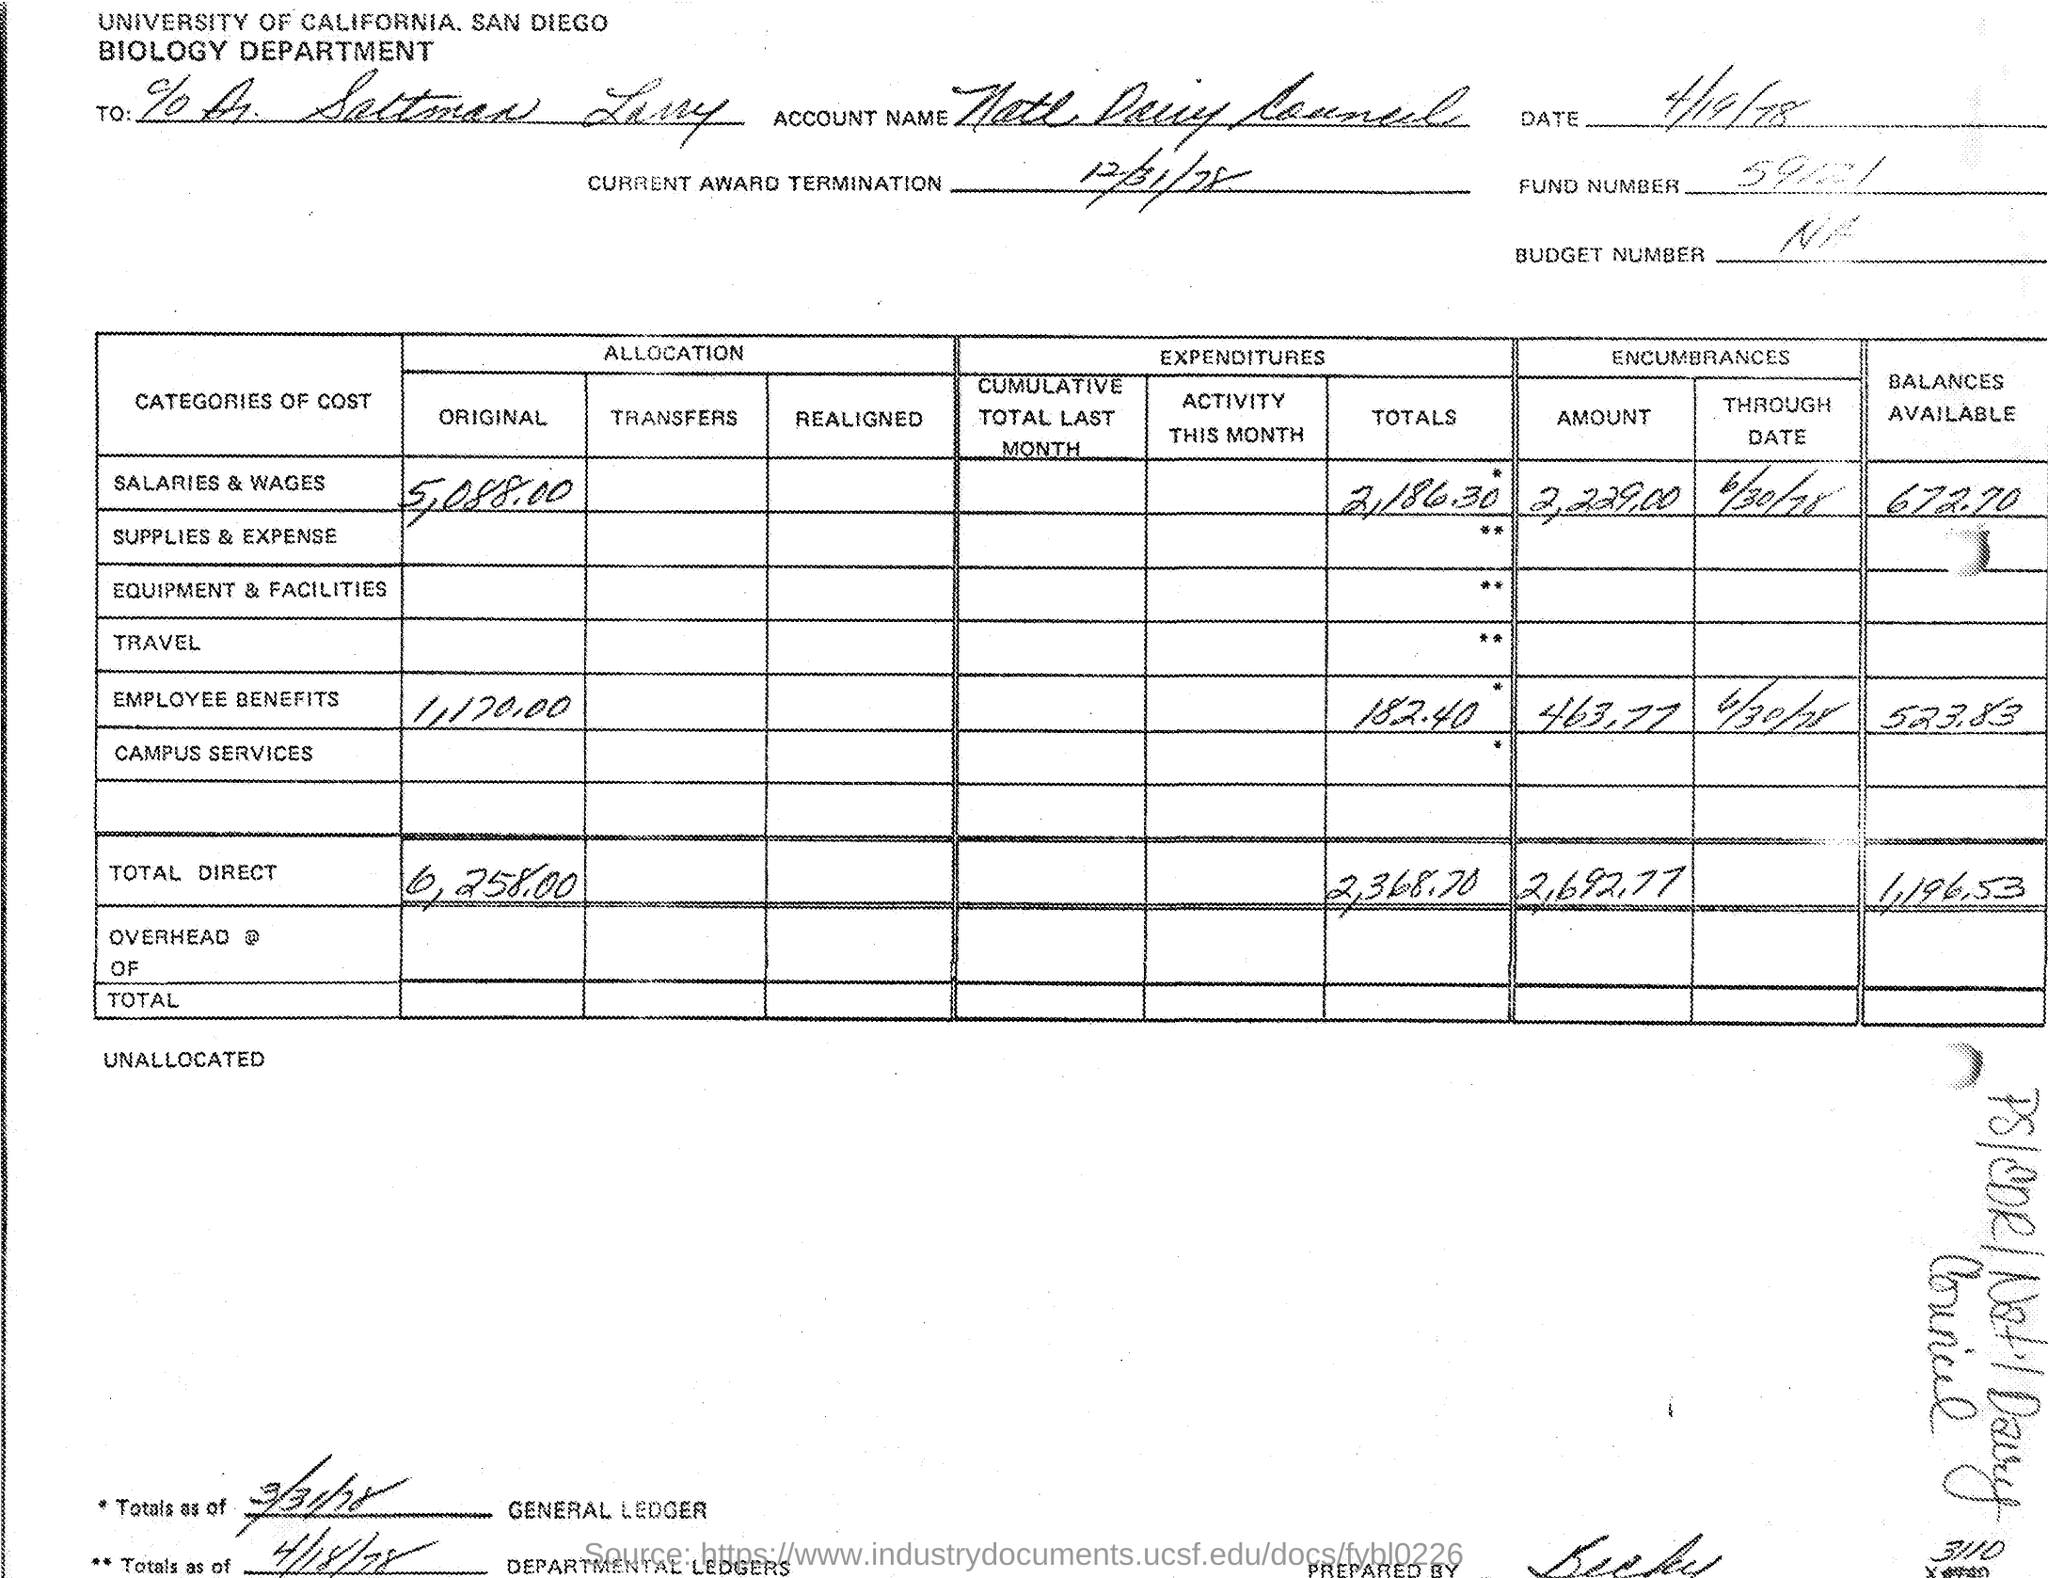Which department details mentioned in the document?
Offer a terse response. BIOLOGY DEPARTMENT. What is the date mentioned in the bill?
Make the answer very short. 4/19/78. What is the Fund Number?
Provide a short and direct response. 59121. What is the Budget Number?
Your answer should be very brief. NA. Where is the location of Biology Department?
Make the answer very short. UNIVERSITY OF CALIFORNIA, SAN DIEGO. 